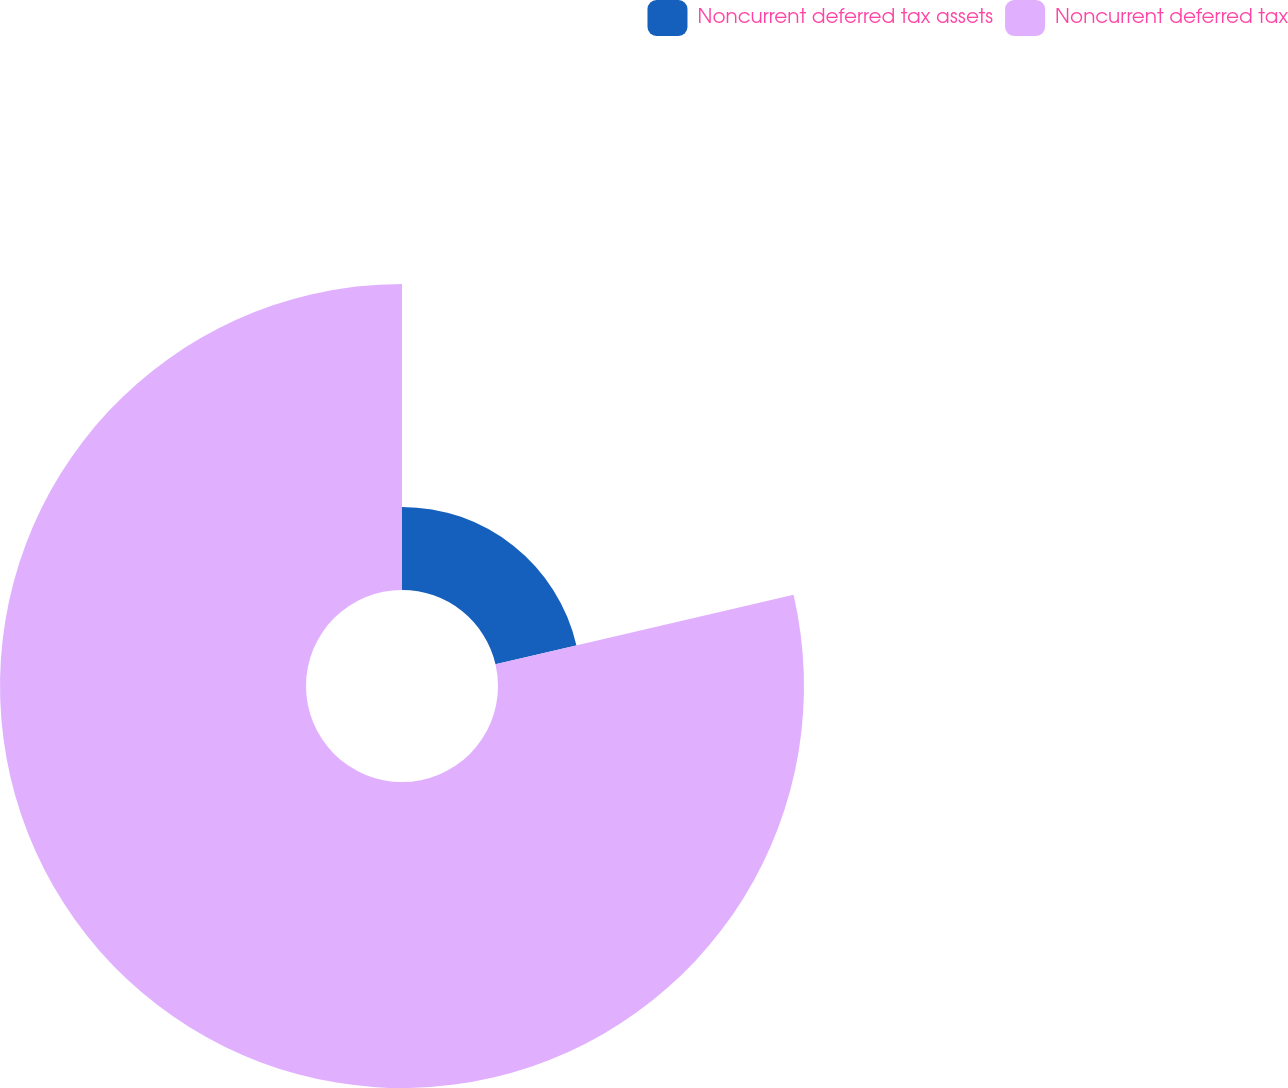Convert chart to OTSL. <chart><loc_0><loc_0><loc_500><loc_500><pie_chart><fcel>Noncurrent deferred tax assets<fcel>Noncurrent deferred tax<nl><fcel>21.36%<fcel>78.64%<nl></chart> 